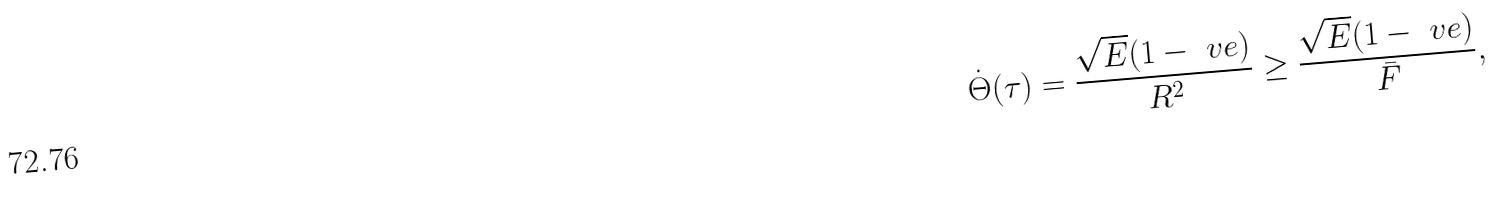Convert formula to latex. <formula><loc_0><loc_0><loc_500><loc_500>\dot { \Theta } ( \tau ) = \frac { \sqrt { E } ( 1 - \ v e ) } { R ^ { 2 } } \geq \frac { \sqrt { E } ( 1 - \ v e ) } { \bar { F } } ,</formula> 